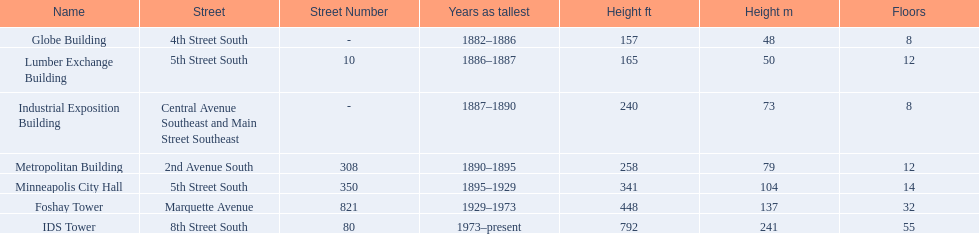What are the tallest buildings in minneapolis? Globe Building, Lumber Exchange Building, Industrial Exposition Building, Metropolitan Building, Minneapolis City Hall, Foshay Tower, IDS Tower. What is the height of the metropolitan building? 258 (79). What is the height of the lumber exchange building? 165 (50). Of those two which is taller? Metropolitan Building. 